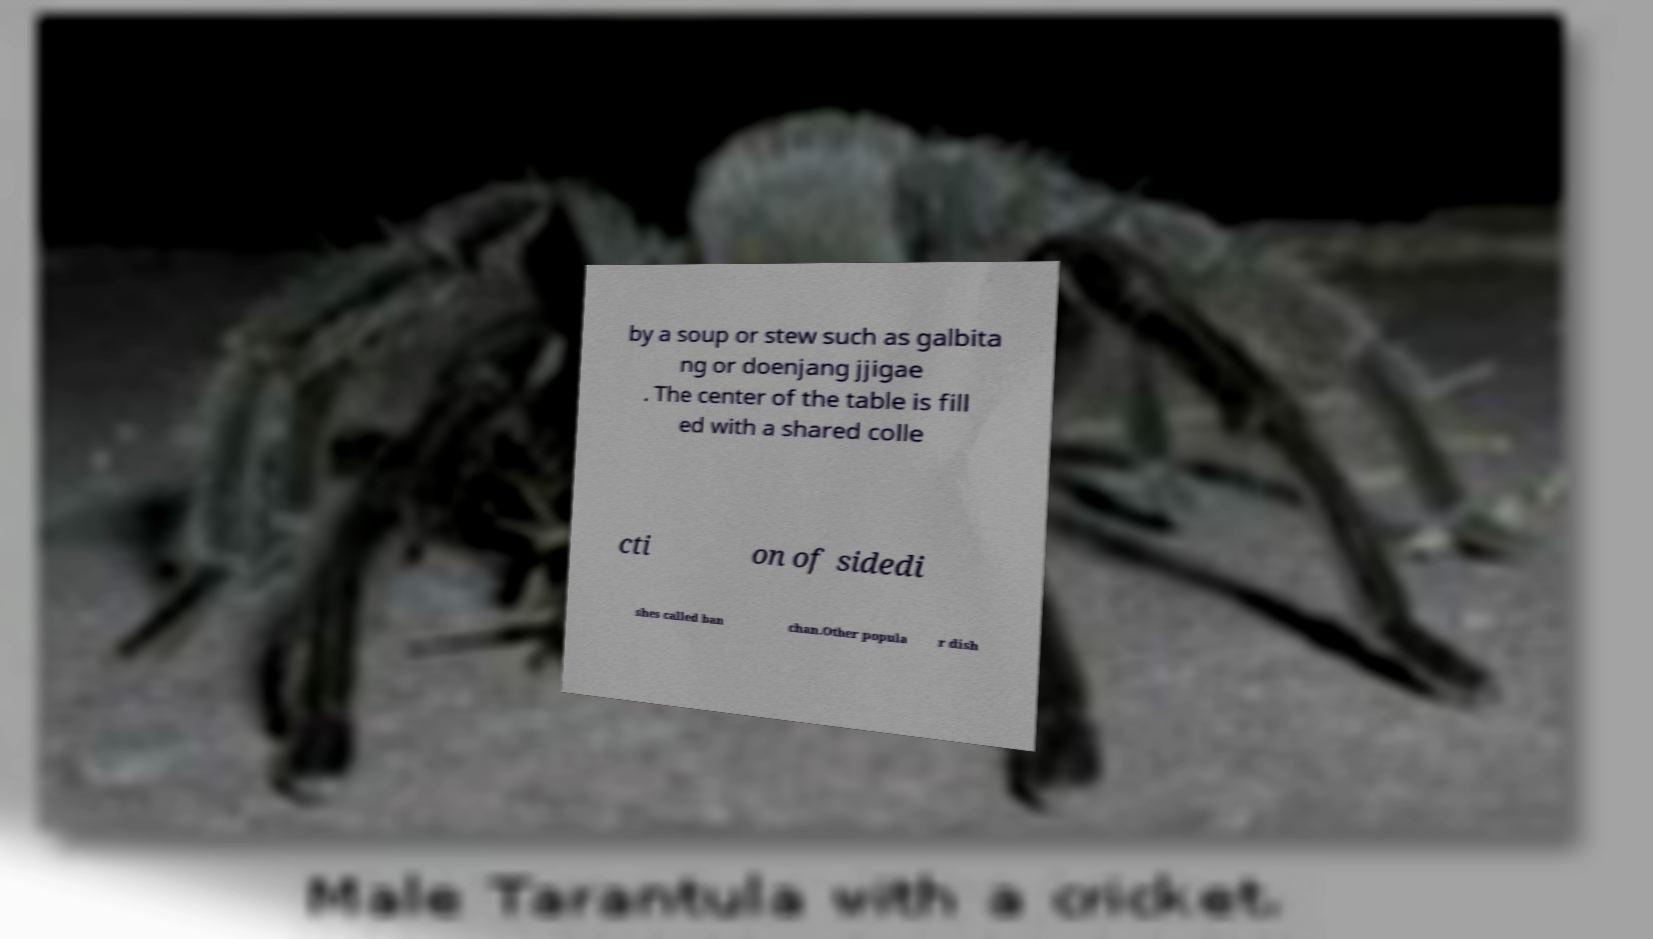I need the written content from this picture converted into text. Can you do that? by a soup or stew such as galbita ng or doenjang jjigae . The center of the table is fill ed with a shared colle cti on of sidedi shes called ban chan.Other popula r dish 